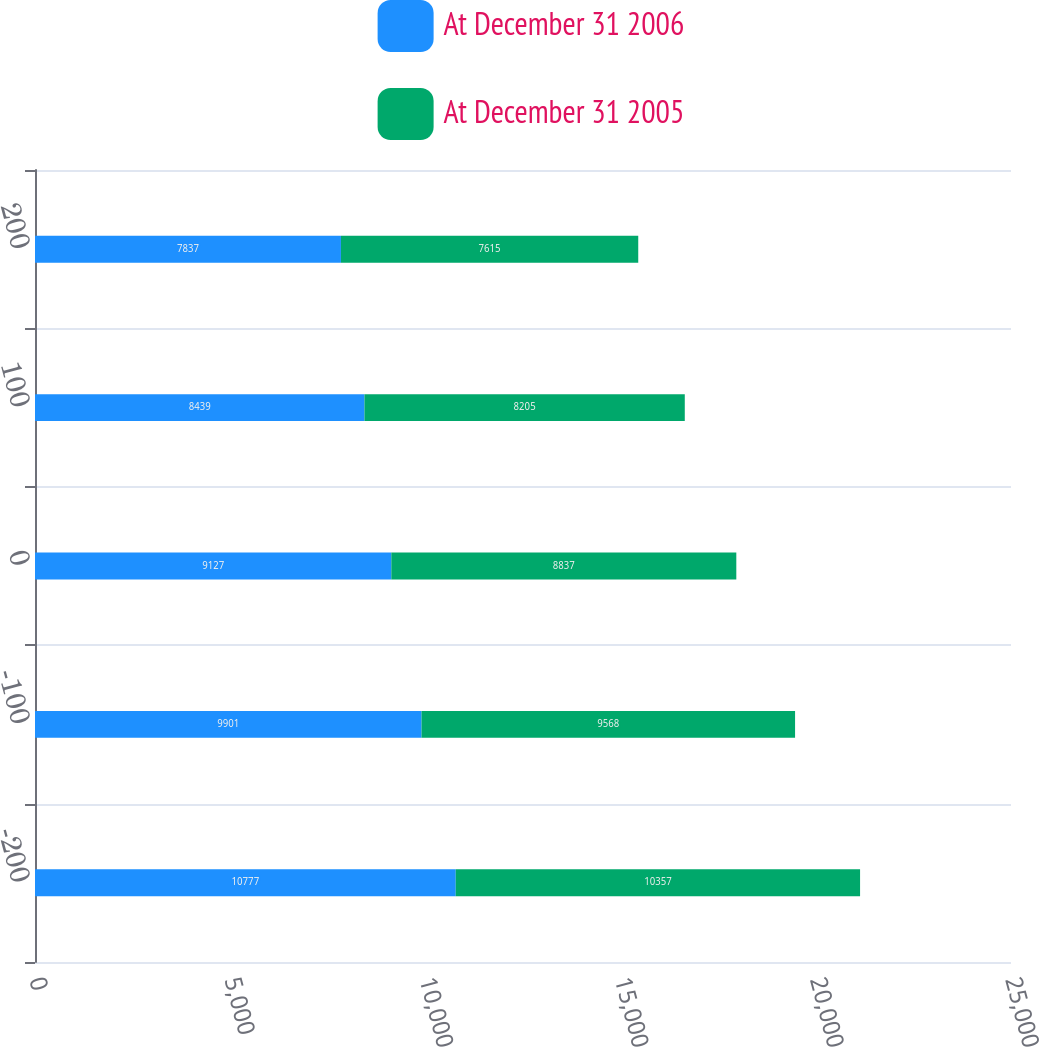Convert chart. <chart><loc_0><loc_0><loc_500><loc_500><stacked_bar_chart><ecel><fcel>-200<fcel>-100<fcel>0<fcel>100<fcel>200<nl><fcel>At December 31 2006<fcel>10777<fcel>9901<fcel>9127<fcel>8439<fcel>7837<nl><fcel>At December 31 2005<fcel>10357<fcel>9568<fcel>8837<fcel>8205<fcel>7615<nl></chart> 